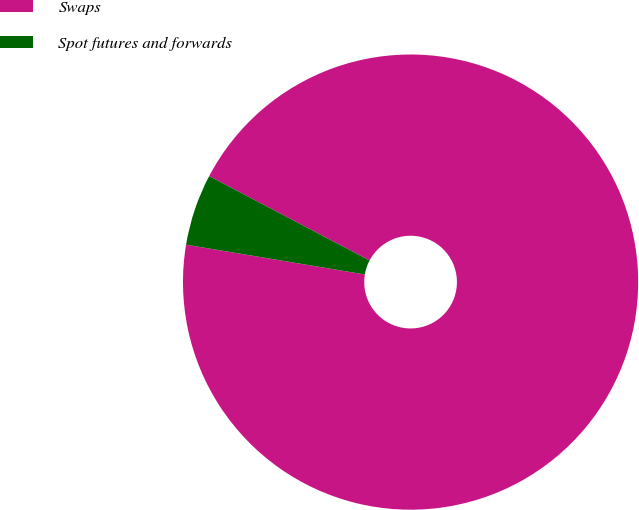Convert chart. <chart><loc_0><loc_0><loc_500><loc_500><pie_chart><fcel>Swaps<fcel>Spot futures and forwards<nl><fcel>94.92%<fcel>5.08%<nl></chart> 